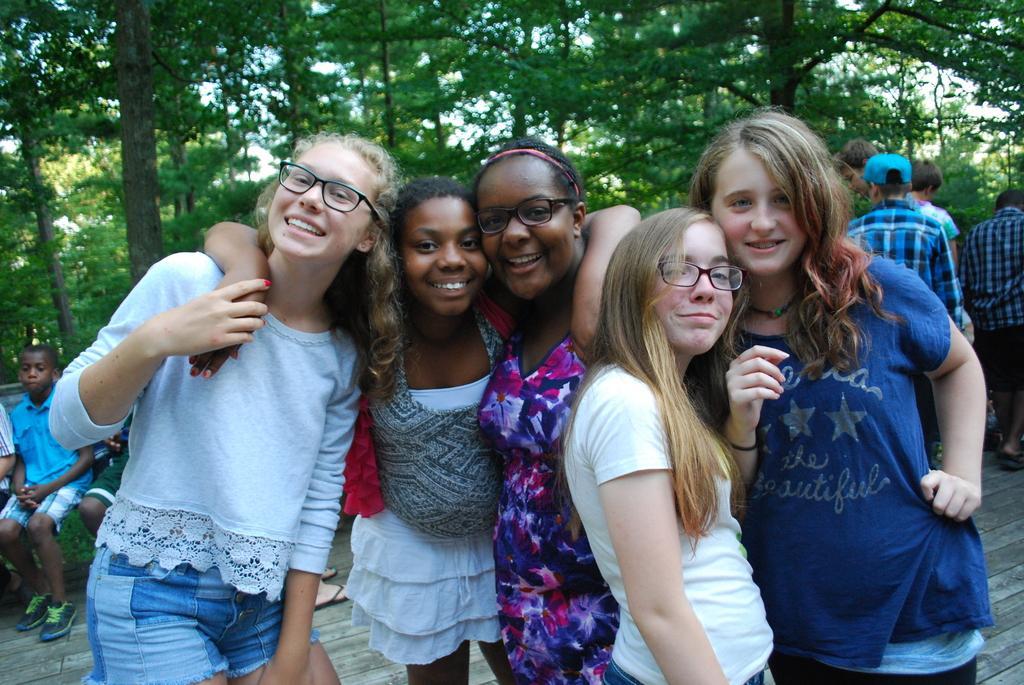Please provide a concise description of this image. In the picture I can see among them some are standing and some are sitting. The people in front of the image are smiling and some of them are wearing spectacles. In the background I can see trees. 